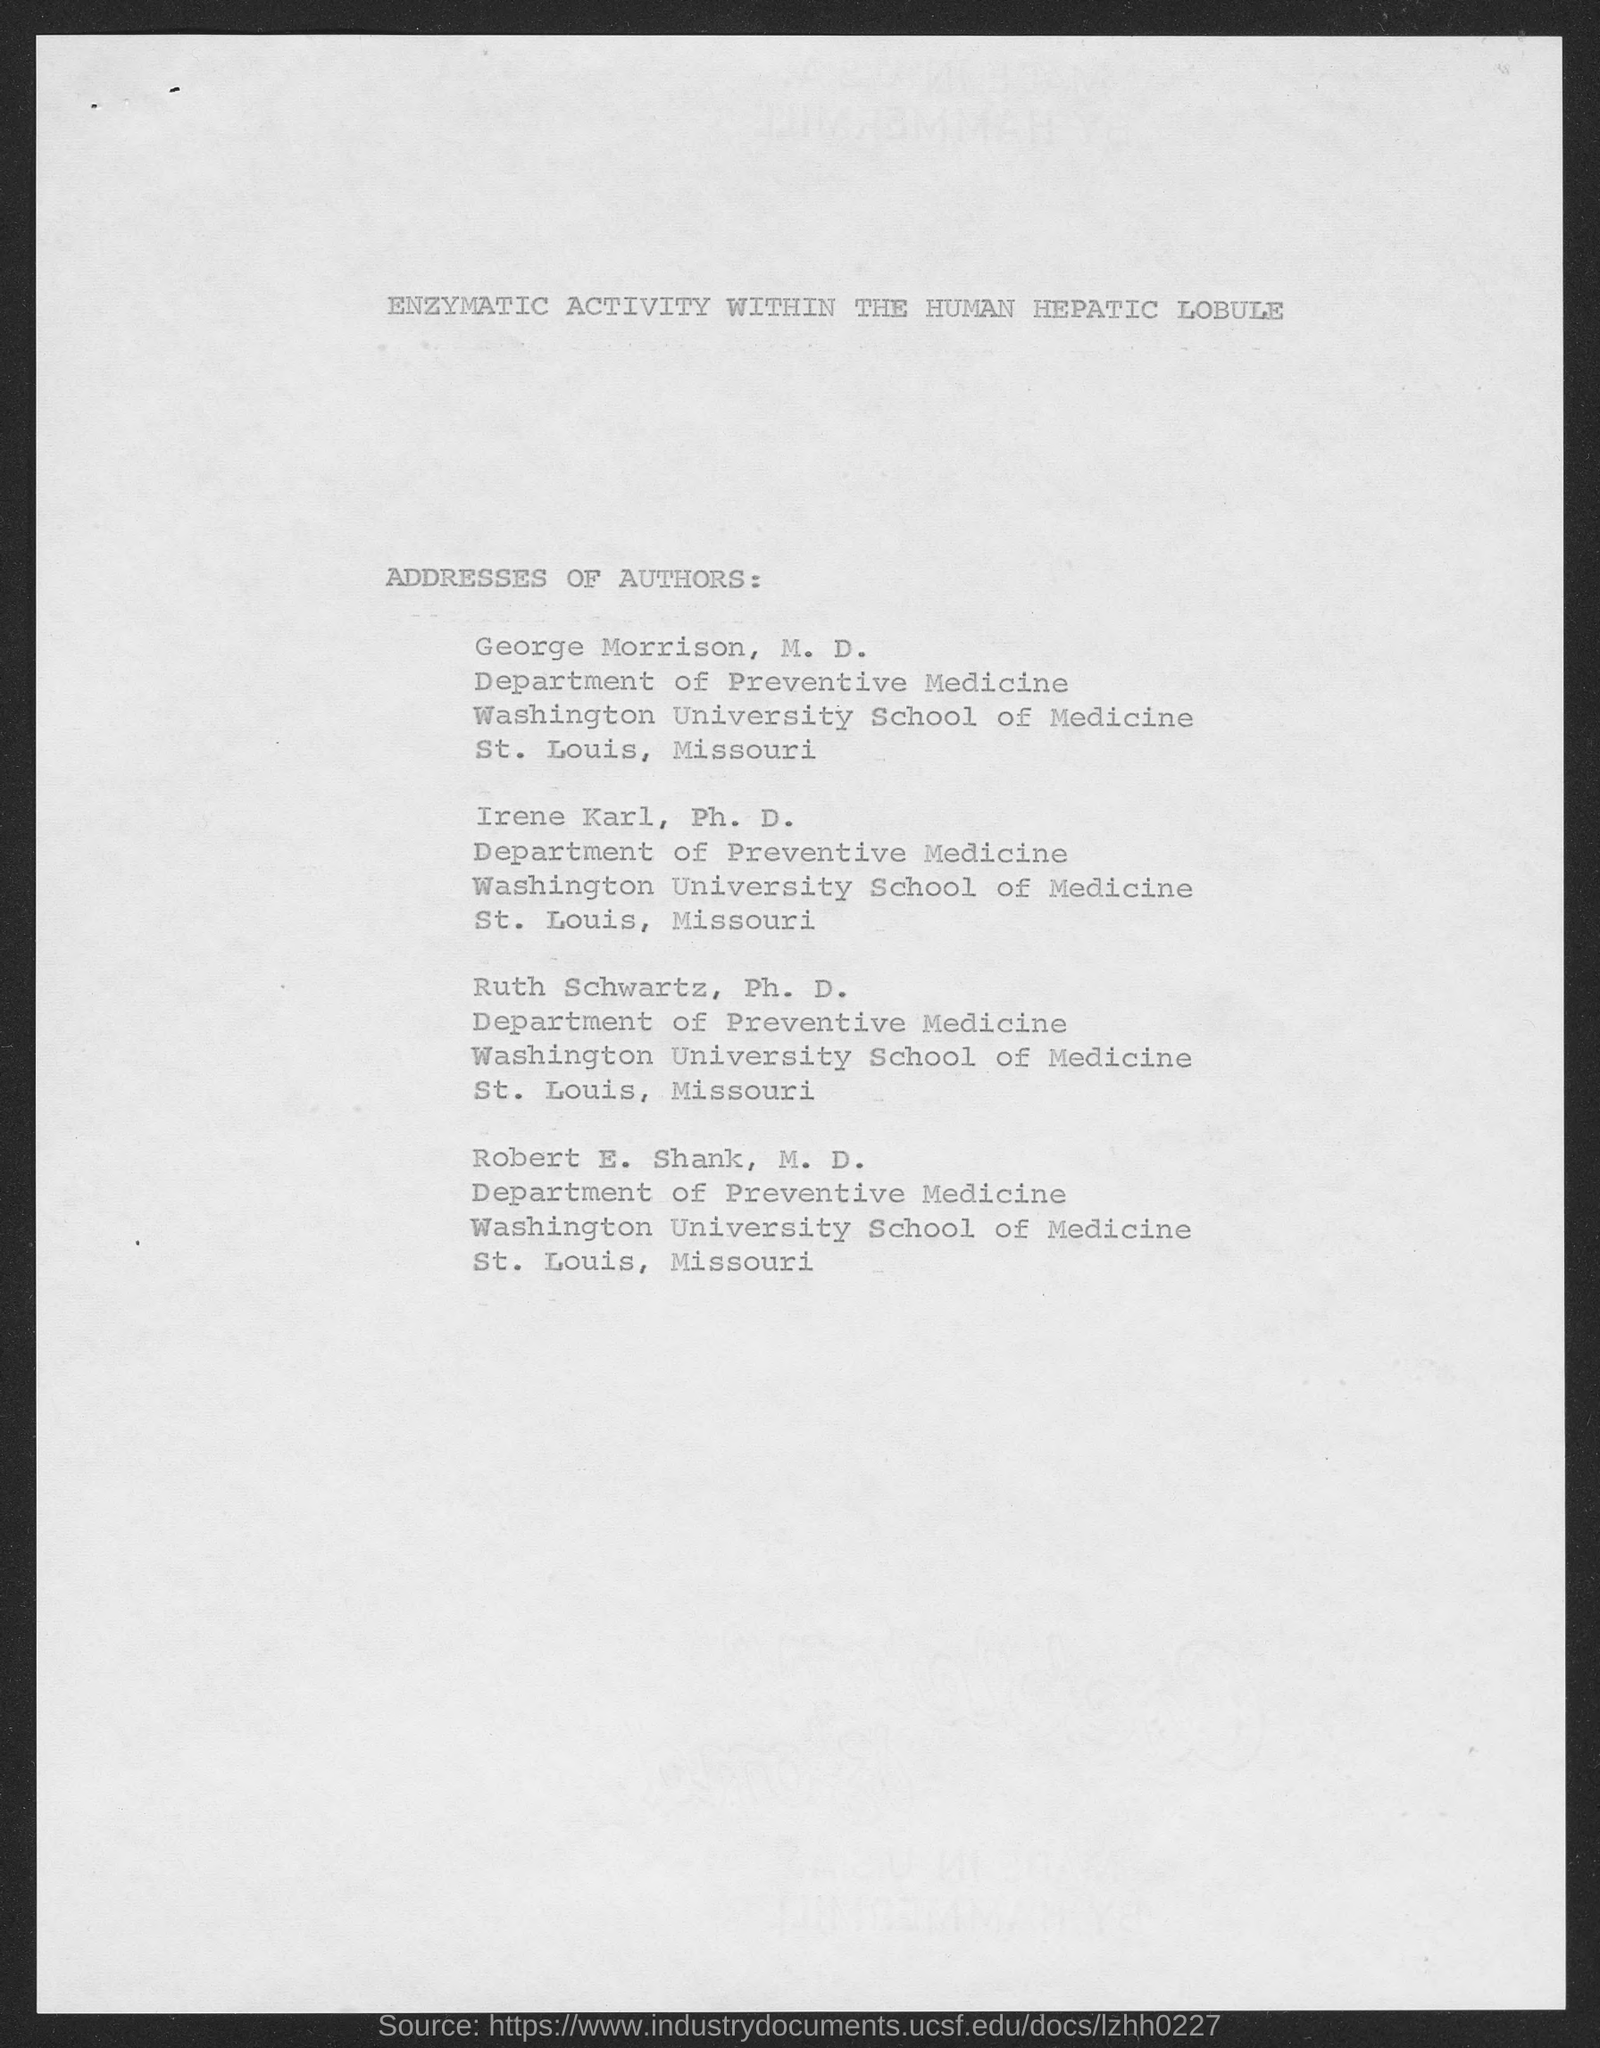What is the title of the document?
Keep it short and to the point. ENZYMATIC ACTIVITY WITHIN THE HUMAN HEPATIC LOBULE. 